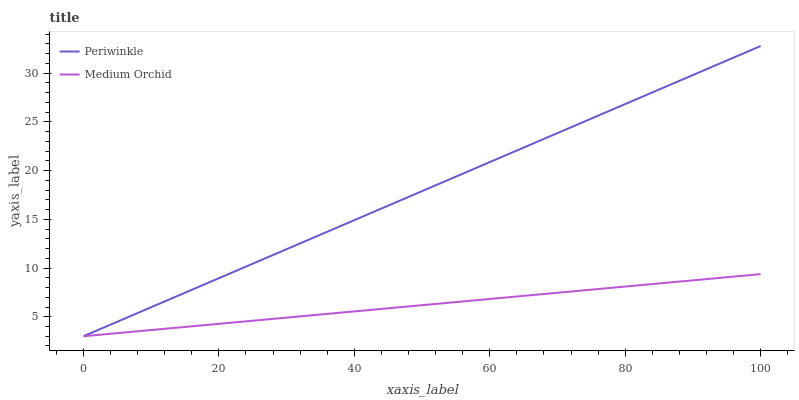Does Periwinkle have the minimum area under the curve?
Answer yes or no. No. Is Periwinkle the roughest?
Answer yes or no. No. 